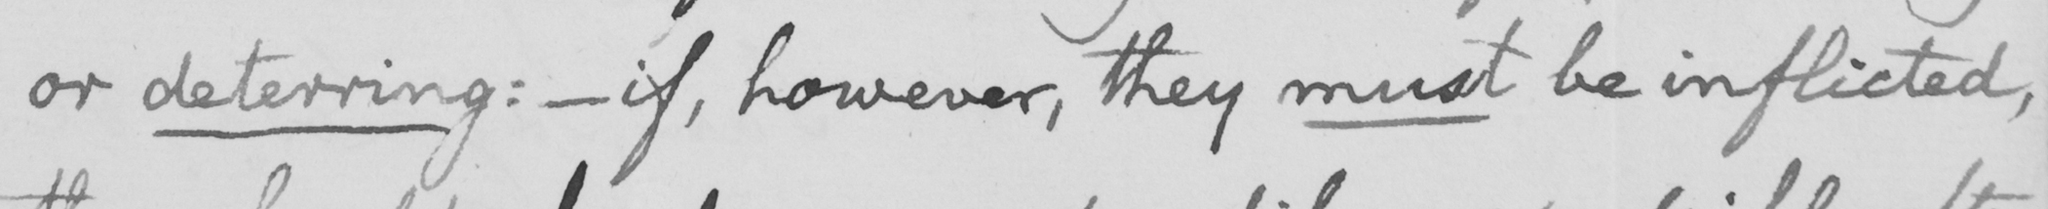Can you tell me what this handwritten text says? or deterring: _ if, however, they must be inflicted, 